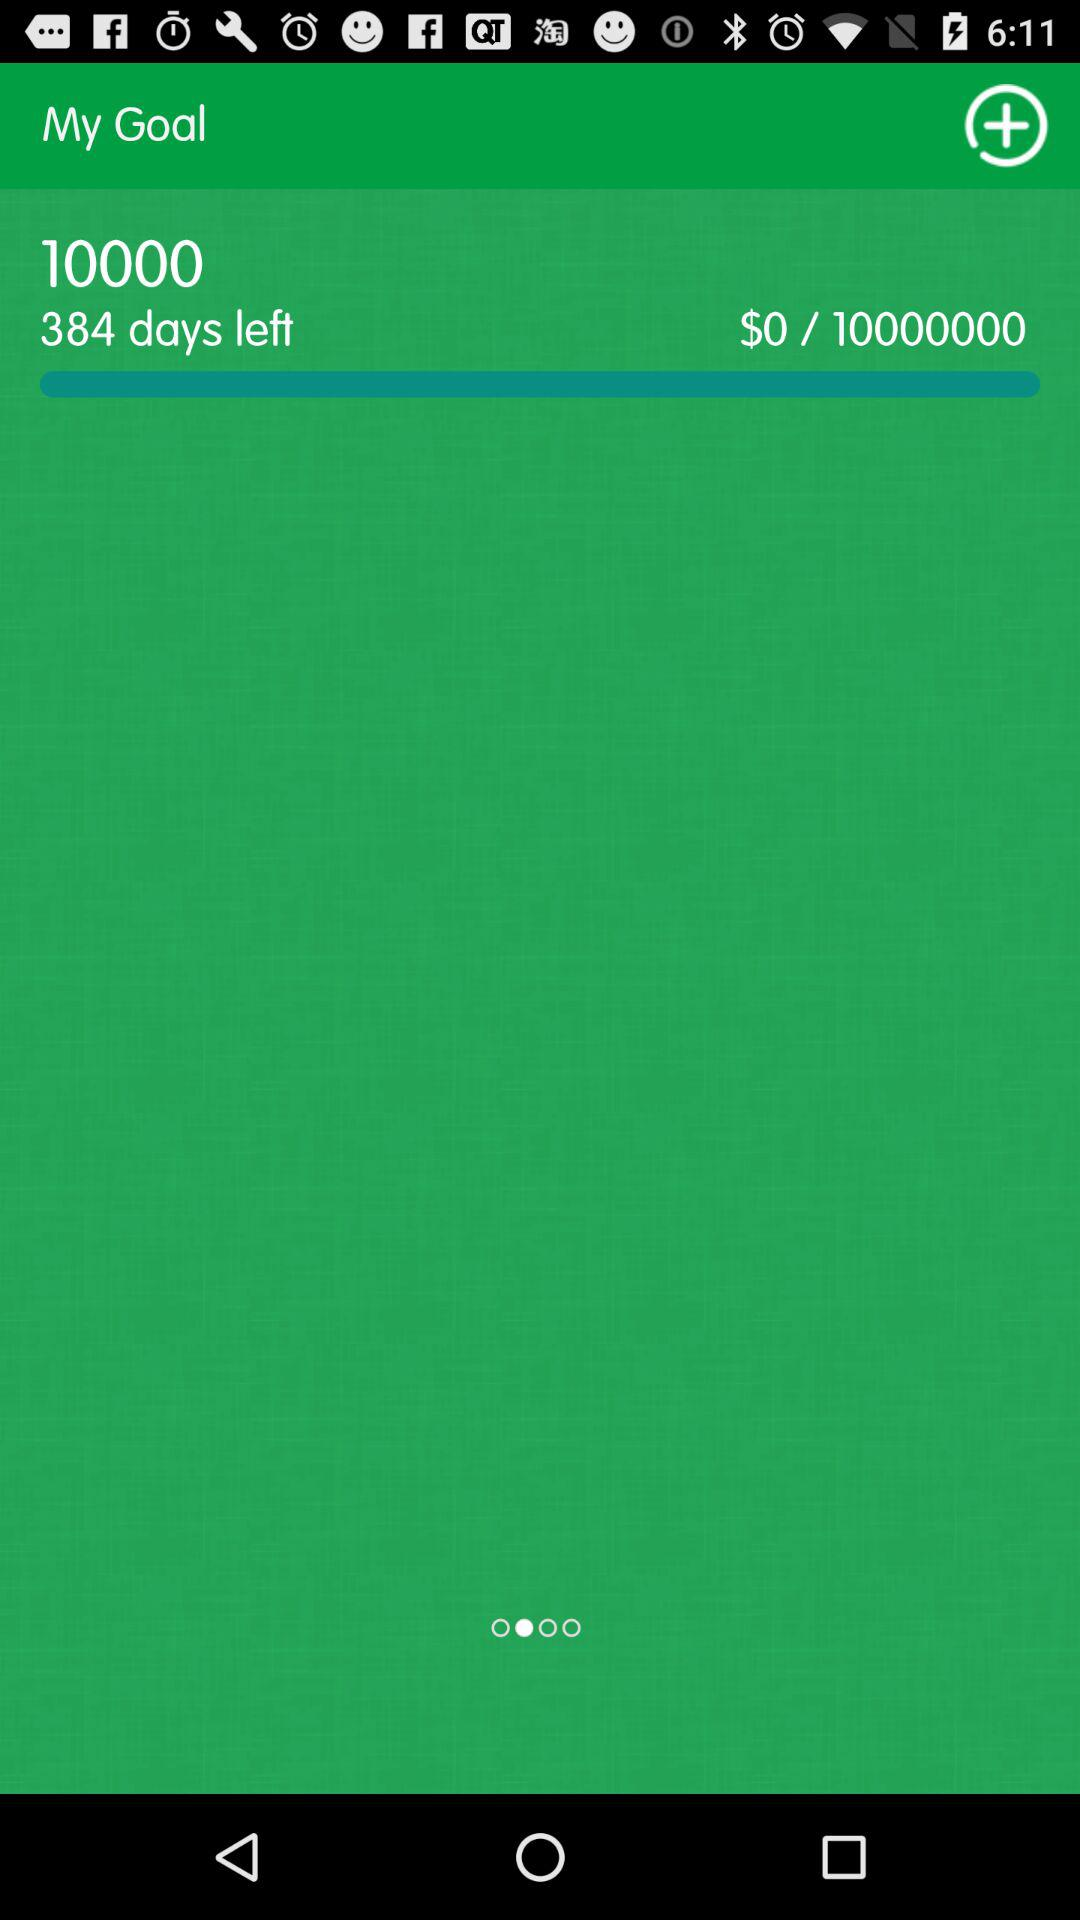How many days are left to reach the goal?
Answer the question using a single word or phrase. 384 